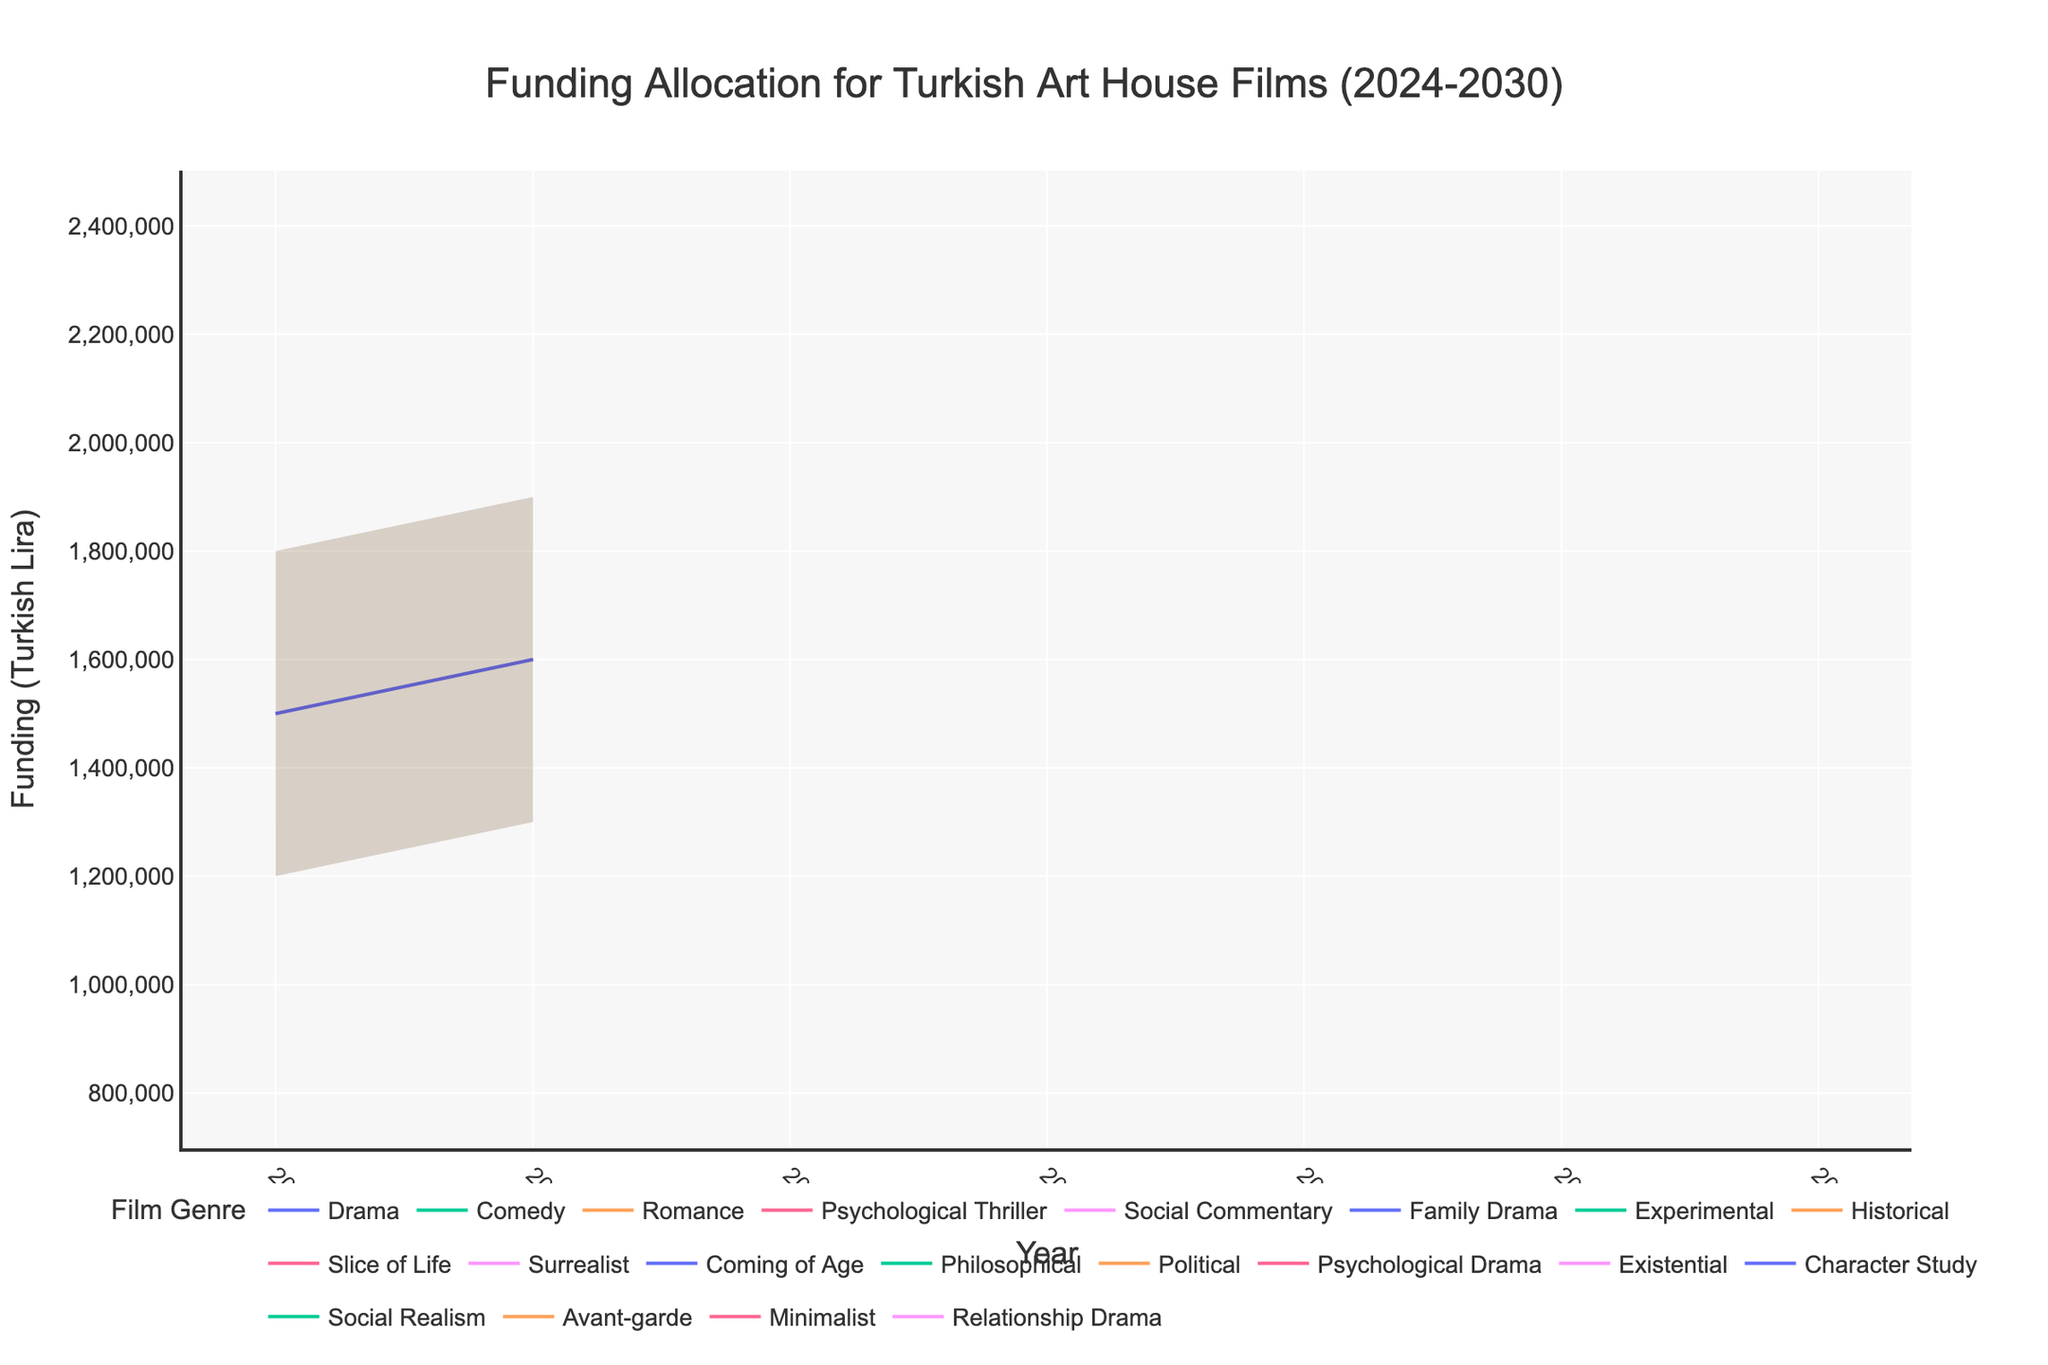Which genre has the highest forecasted funding (Medium) for the year 2028? The figure shows that the genre with the highest medium forecasted funding for 2028 is "Philosophical" with 1,900,000 Turkish Lira.
Answer: Philosophical What is the range of the estimated funding allocation for "Drama" in 2025? The range is calculated by subtracting the Low estimate from the High estimate. For Drama in 2025, the High estimate is 1,900,000 TL, and the Low estimate is 1,300,000 TL. Thus, the range is 1,900,000 - 1,300,000 = 600,000 TL.
Answer: 600,000 TL Compare the forecasted medium funding allocation for "Surrealist" in 2027 and "Existential" in 2029. Which one is higher and by how much? The medium forecasted funding for Surrealist in 2027 is 1,300,000 TL, and for Existential in 2029 is 2,000,000 TL. The difference is 2,000,000 - 1,300,000 = 700,000 TL.
Answer: Existential by 700,000 TL What is the average forecasted funding (Medium) for "High Complexity" genres in 2026? The high complexity genres in 2026 are Family Drama, and Historical. Their medium forecasted fundings are 1,700,000 TL (Family Drama) and 1,500,000 TL (Historical). The average is (1,700,000 + 1,500,000) / 2 = 1,600,000 TL.
Answer: 1,600,000 TL Which year has the highest combined medium forecasted funding for "High Complexity" genres? Summing up the medium forecasted funding for high complexity genres in each year, we find: 2024 (Drama: 1,500,000 + Romance: 1,100,000 = 2,600,000 TL), 2025 (Drama: 1,600,000 + Social Commentary: 1,300,000 = 2,900,000 TL), 2026 (Family Drama: 1,700,000 + Historical: 1,500,000 = 3,200,000 TL), 2027 (Slice of Life: 1,800,000 + Coming of Age: 1,600,000 = 3,400,000 TL), 2028 (Political: 1,700,000 + Psychological Drama: 1,800,000 = 3,500,000 TL), 2029 (Character Study: 1,900,000 + Social Realism: 1,800,000 = 3,700,000 TL), and 2030 (Minimalist: 1,700,000 + Relationship Drama: 2,000,000 = 3,700,000 TL). The years with the highest combined funding are 2029 and 2030, with 3,700,000 TL each.
Answer: 2029 and 2030 What is the expected increase in medium forecasted funding for the "Experimental" genre from 2026 to 2030? The medium forecasted funding for Experimental in 2026 is 1,200,000 TL. There is no data for Experimental in 2030 specifically in the data provided, but assuming potential projection could be derived from available genres with similar complexities, the question might need reviewing for fitting the dataset.
Answer: Cannot be determined 